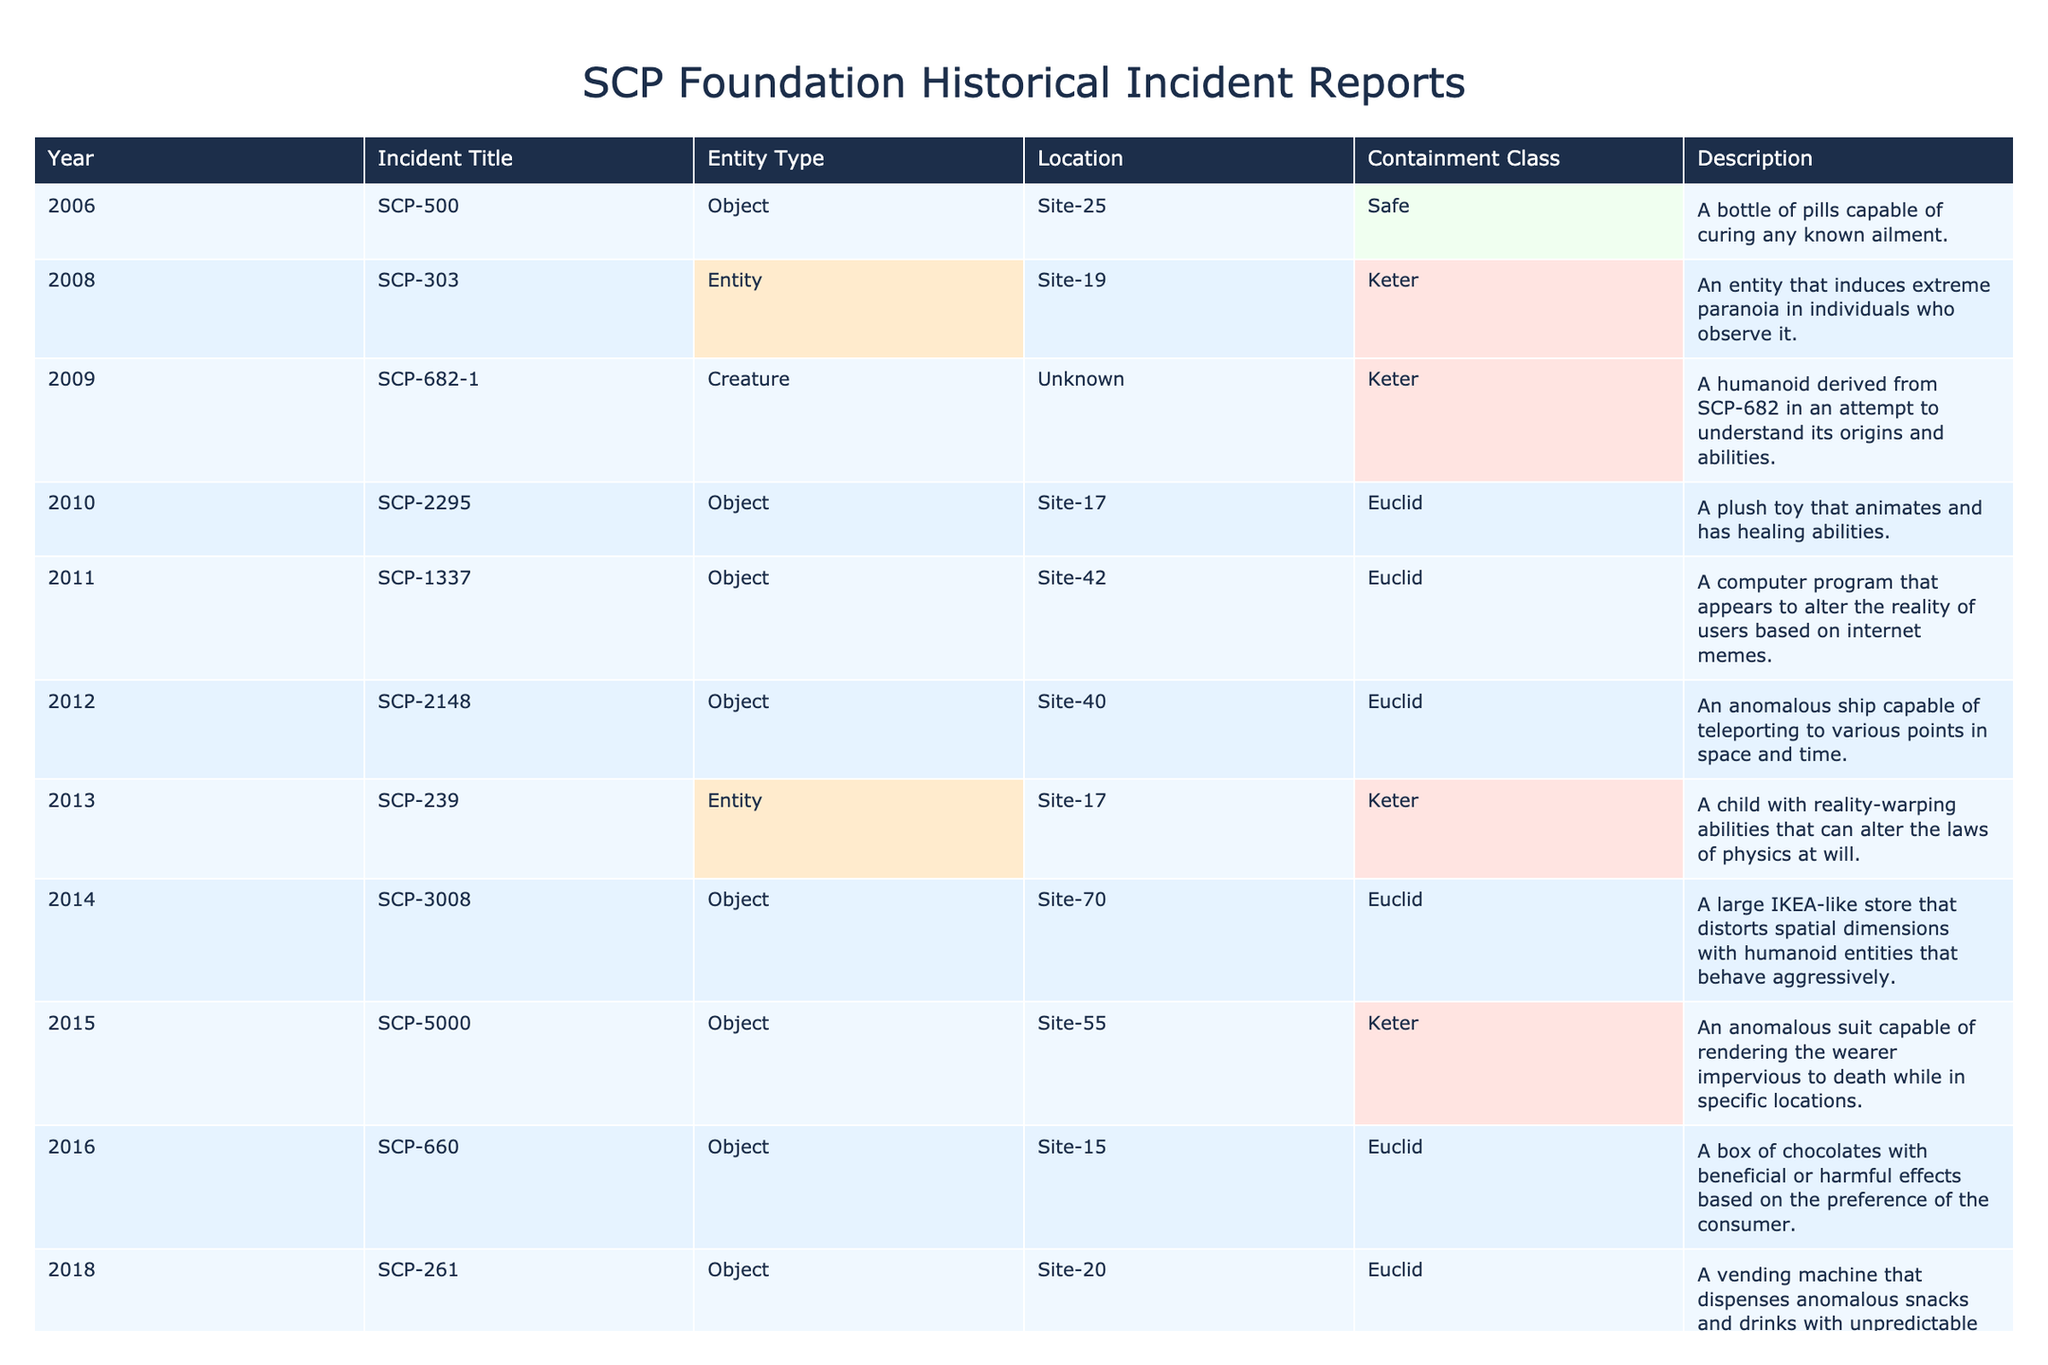What was the title of the incident reported in 2011? The table lists the incidents by year. By locating the row corresponding to 2011, we see that the title of the incident is "SCP-1337."
Answer: SCP-1337 How many incidents are designated as Keter? To find the number of incidents classified as Keter, we count the rows where the containment class is listed as Keter. In the table, there are 6 instances of Keter.
Answer: 6 Which entity was reported in 2009 and what was its containment class? We locate the entry for the year 2009 in the table. The incident reported is "SCP-682-1," and its containment class is Keter.
Answer: SCP-682-1, Keter What percentage of the incidents reported are classified as Euclid? First, we count the total number of incidents, which is 18. Next, we count the number of incidents classified as Euclid, which totals 7. The percentage is therefore calculated as (7 / 18) * 100, which equals approximately 38.89%.
Answer: 38.89% Is SCP-500 classified as an object or an entity? In the table, we can easily check the row for SCP-500 and see that it is classified as an object.
Answer: Yes, an object Which year saw the most recently reported incident, and what was its title? The last row of the table corresponds to the year 2023. The title of the incident from that year is "SCP-7777."
Answer: 2023, SCP-7777 How many incidents involved objects compared to entities? We assess the total number of incidents listed, totaling 18. According to the table, there are 12 objects and 6 entities. Thus, we have a total of 12 objects versus 6 entities.
Answer: 12 objects, 6 entities Which incident has the ability to alter reality according to its description? We read through the descriptions in the table. The entries for SCP-239 and SCP-1337 (among others) mention the ability to alter reality. However, SCP-239 has reality-warping abilities specifically noted.
Answer: SCP-239 